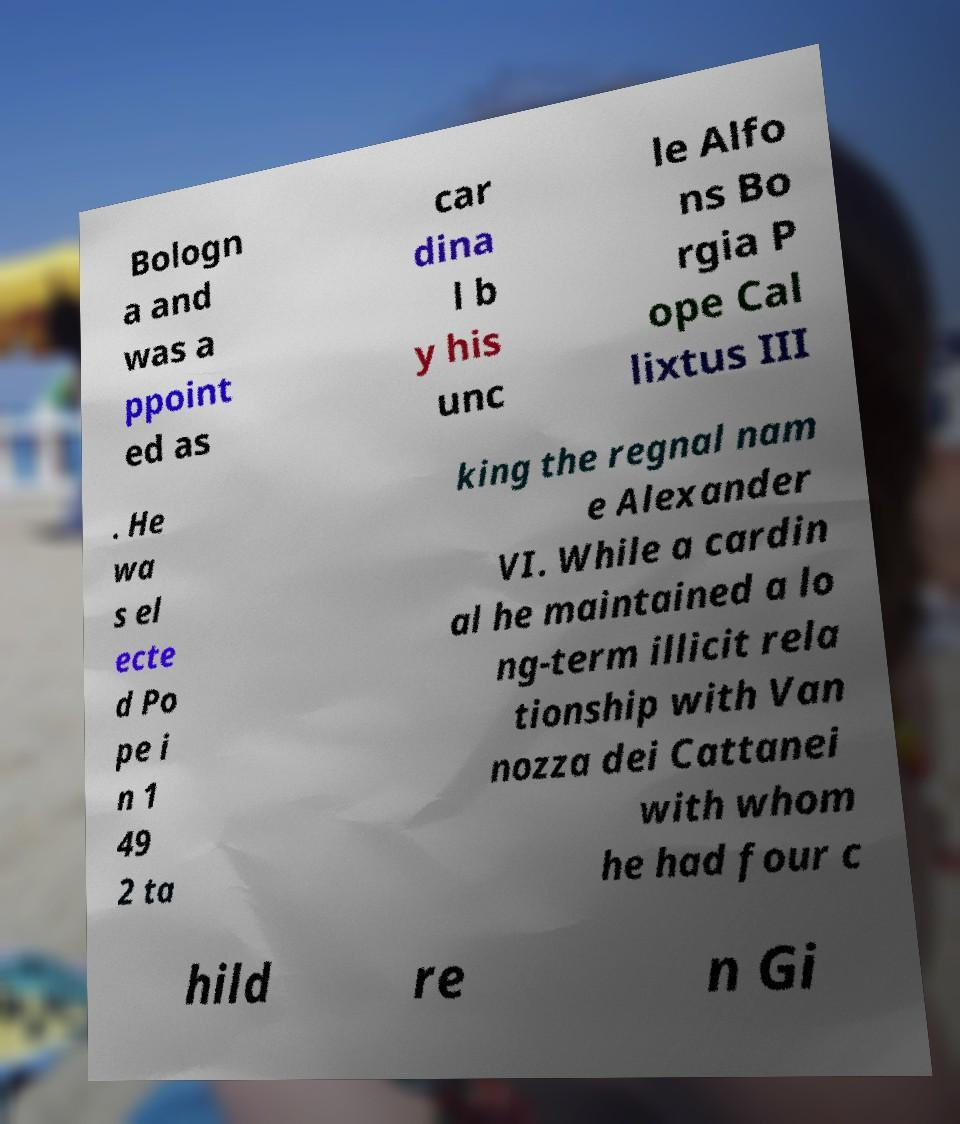For documentation purposes, I need the text within this image transcribed. Could you provide that? Bologn a and was a ppoint ed as car dina l b y his unc le Alfo ns Bo rgia P ope Cal lixtus III . He wa s el ecte d Po pe i n 1 49 2 ta king the regnal nam e Alexander VI. While a cardin al he maintained a lo ng-term illicit rela tionship with Van nozza dei Cattanei with whom he had four c hild re n Gi 